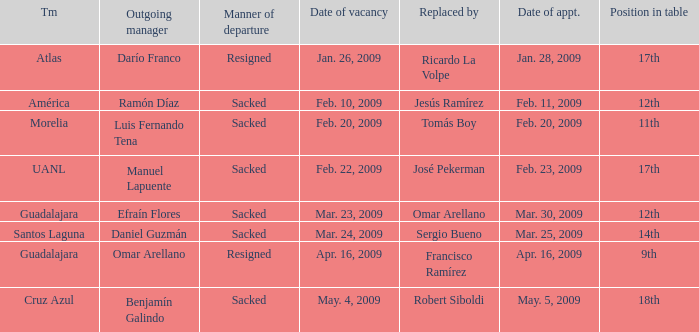What is Position in Table, when Team is "Morelia"? 11th. 